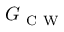Convert formula to latex. <formula><loc_0><loc_0><loc_500><loc_500>G _ { C W }</formula> 